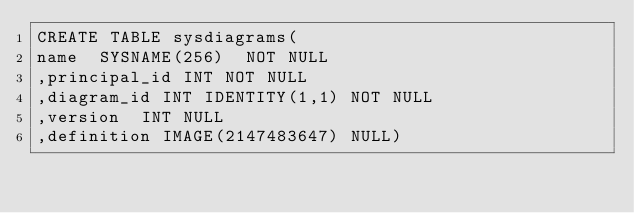<code> <loc_0><loc_0><loc_500><loc_500><_SQL_>CREATE TABLE sysdiagrams(
name	SYSNAME(256)	NOT NULL
,principal_id	INT	NOT NULL
,diagram_id	INT IDENTITY(1,1)	NOT NULL
,version	INT	NULL
,definition	IMAGE(2147483647)	NULL)</code> 